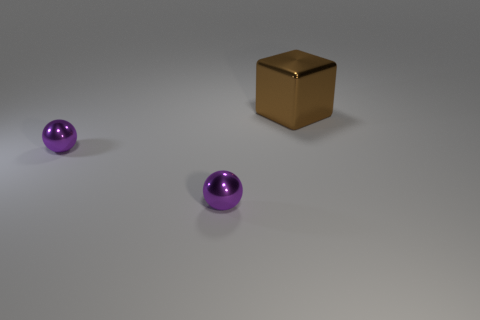Subtract all cubes. How many objects are left? 2 Add 2 brown shiny things. How many objects exist? 5 Subtract all purple rubber cylinders. Subtract all large objects. How many objects are left? 2 Add 1 big objects. How many big objects are left? 2 Add 1 metal spheres. How many metal spheres exist? 3 Subtract 0 green cylinders. How many objects are left? 3 Subtract all blue spheres. Subtract all cyan cylinders. How many spheres are left? 2 